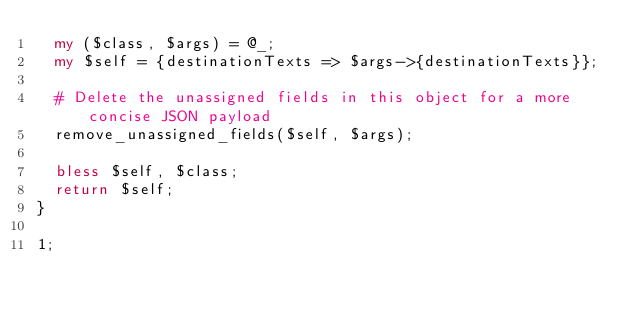Convert code to text. <code><loc_0><loc_0><loc_500><loc_500><_Perl_>  my ($class, $args) = @_;
  my $self = {destinationTexts => $args->{destinationTexts}};

  # Delete the unassigned fields in this object for a more concise JSON payload
  remove_unassigned_fields($self, $args);

  bless $self, $class;
  return $self;
}

1;
</code> 